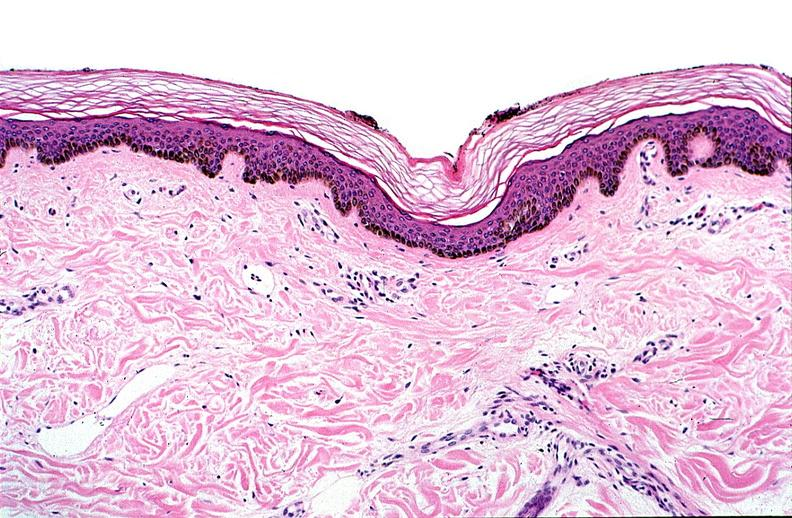where is this?
Answer the question using a single word or phrase. Skin 